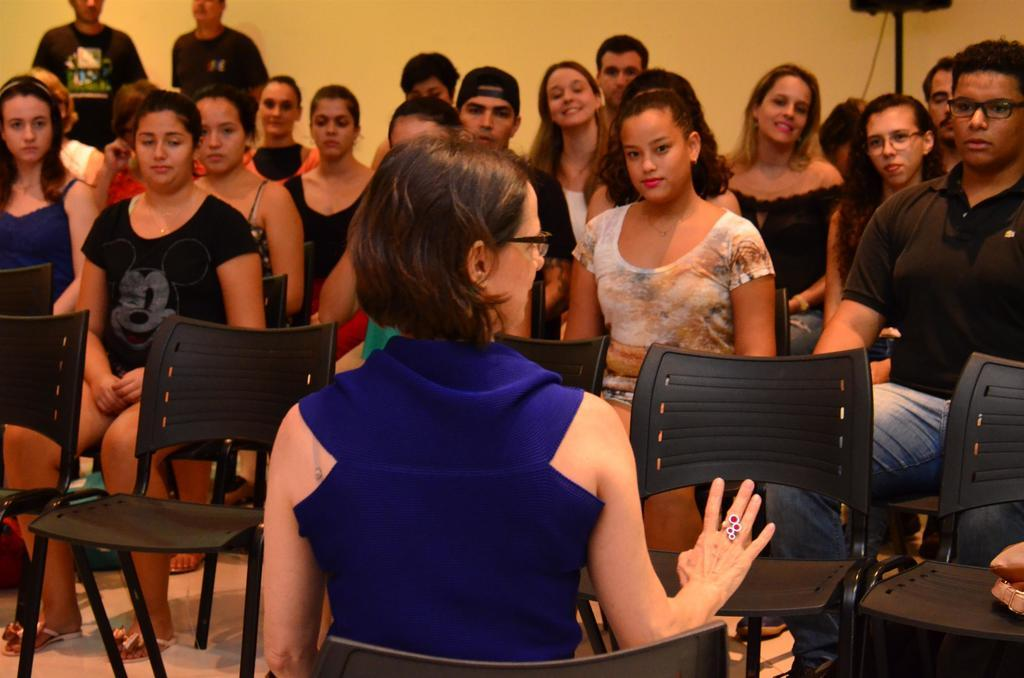What are the people in the image doing? There is a group of people sitting on chairs in the image. Are there any available chairs for others to sit? Yes, there are empty chairs in front of the sitting people. What can be seen in the background of the image? There is a wall in the background of the image. Are there any other people visible in the image? Yes, there are persons standing in the background of the image. What type of farm animals can be seen in the image? There are no farm animals present in the image. How many feet are visible in the image? The image does not show any feet, so it is not possible to determine the number of feet visible. 